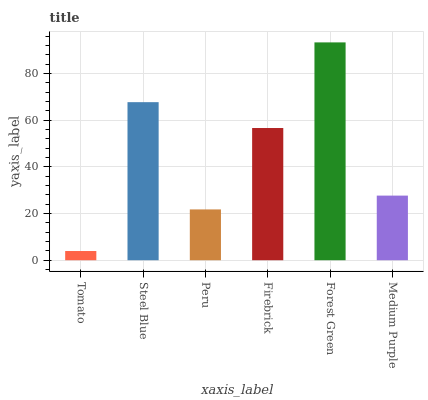Is Tomato the minimum?
Answer yes or no. Yes. Is Forest Green the maximum?
Answer yes or no. Yes. Is Steel Blue the minimum?
Answer yes or no. No. Is Steel Blue the maximum?
Answer yes or no. No. Is Steel Blue greater than Tomato?
Answer yes or no. Yes. Is Tomato less than Steel Blue?
Answer yes or no. Yes. Is Tomato greater than Steel Blue?
Answer yes or no. No. Is Steel Blue less than Tomato?
Answer yes or no. No. Is Firebrick the high median?
Answer yes or no. Yes. Is Medium Purple the low median?
Answer yes or no. Yes. Is Tomato the high median?
Answer yes or no. No. Is Tomato the low median?
Answer yes or no. No. 